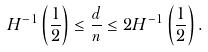<formula> <loc_0><loc_0><loc_500><loc_500>H ^ { - 1 } \left ( \frac { 1 } { 2 } \right ) \leq \frac { d } { n } \leq 2 H ^ { - 1 } \left ( \frac { 1 } { 2 } \right ) .</formula> 